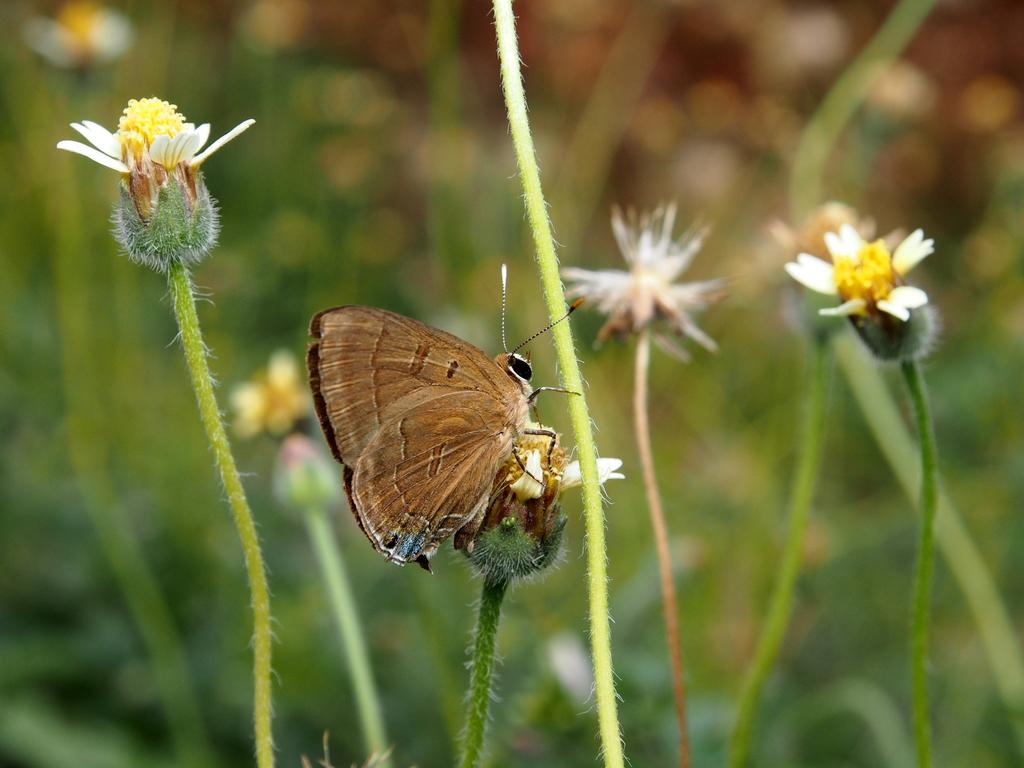What is the main subject of the image? There is a butterfly in the image. Where is the butterfly located? The butterfly is on a flower. What colors can be seen on the butterfly? The butterfly has brown and black colors. What type of flowers are in the image? The flowers have white and yellow colors. How is the background of the image depicted? The background of the image is blurred. What song is the rat singing in the image? There is no rat or song present in the image; it features a butterfly on a flower. What type of music can be heard in the background of the image? There is no music present in the image; it is a still photograph of a butterfly on a flower. 